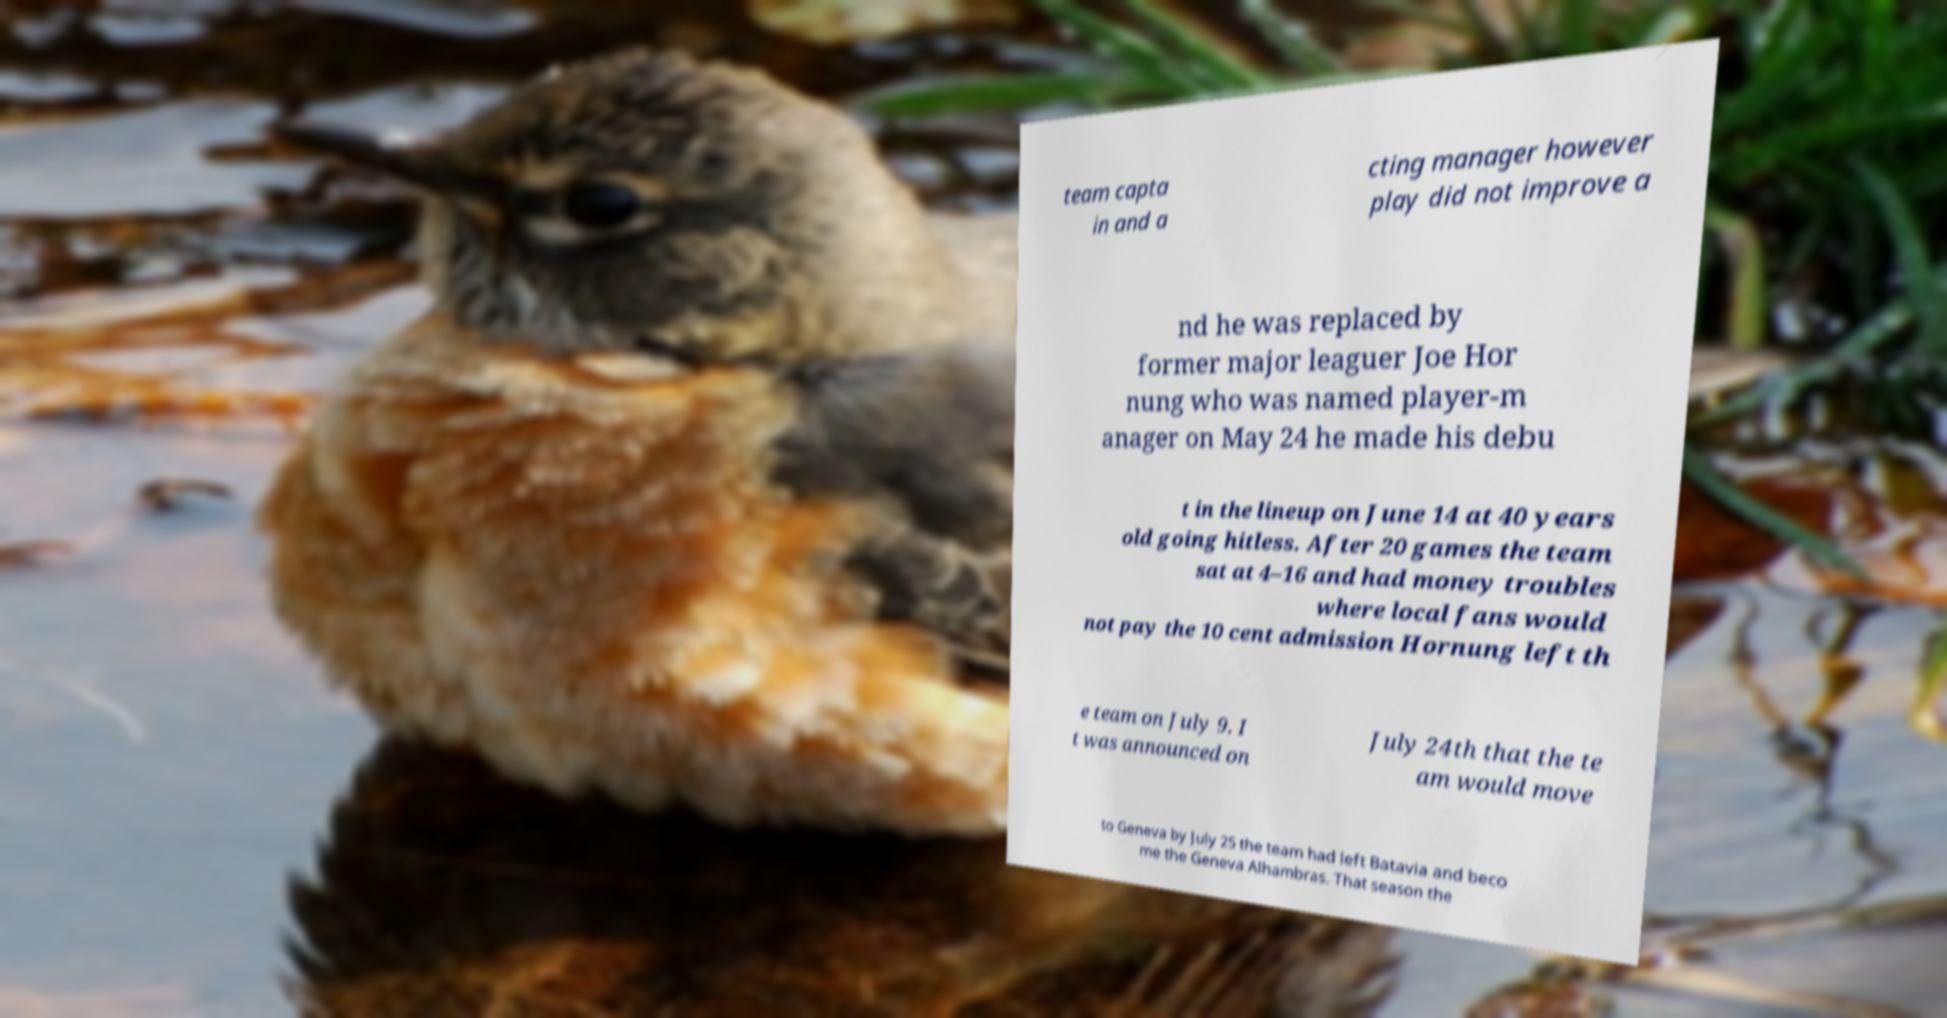Please identify and transcribe the text found in this image. team capta in and a cting manager however play did not improve a nd he was replaced by former major leaguer Joe Hor nung who was named player-m anager on May 24 he made his debu t in the lineup on June 14 at 40 years old going hitless. After 20 games the team sat at 4–16 and had money troubles where local fans would not pay the 10 cent admission Hornung left th e team on July 9. I t was announced on July 24th that the te am would move to Geneva by July 25 the team had left Batavia and beco me the Geneva Alhambras. That season the 